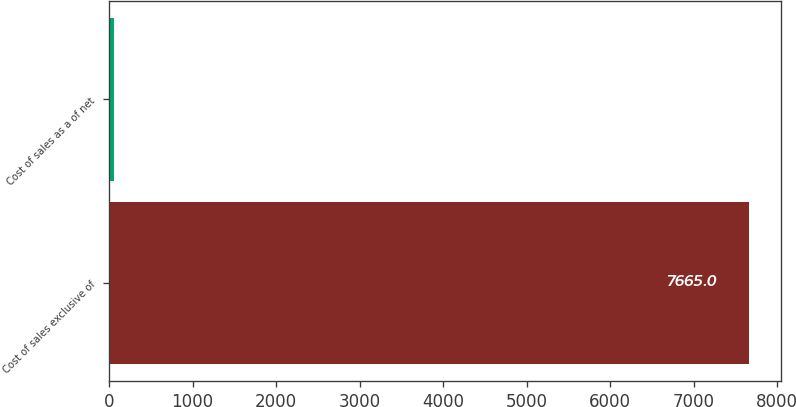<chart> <loc_0><loc_0><loc_500><loc_500><bar_chart><fcel>Cost of sales exclusive of<fcel>Cost of sales as a of net<nl><fcel>7665<fcel>53.7<nl></chart> 